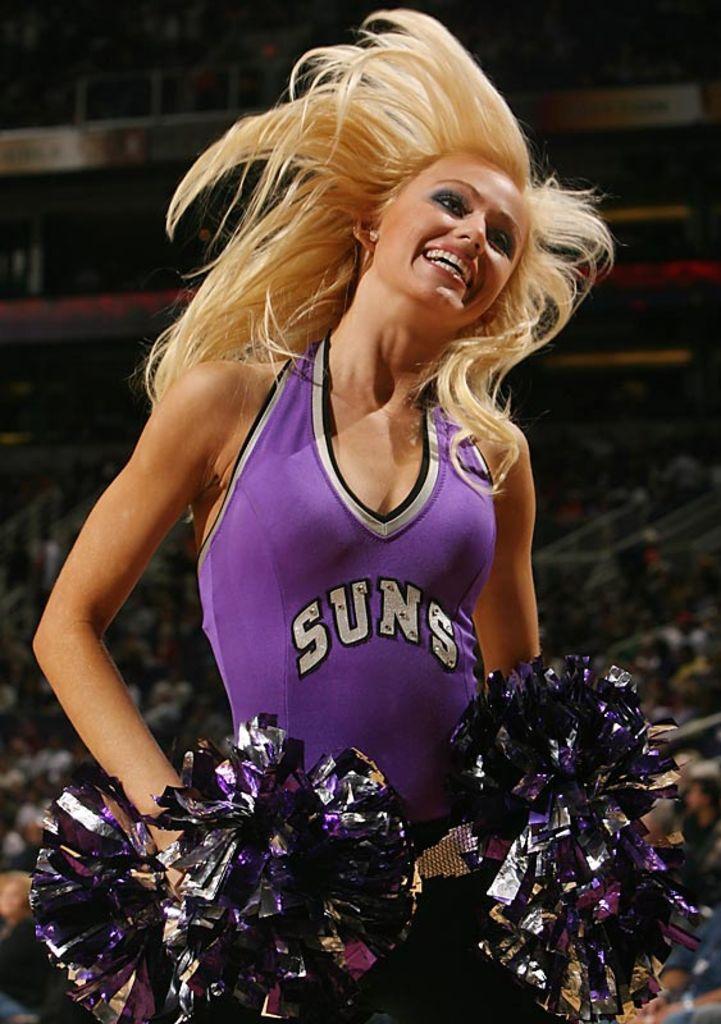What team does this cheerleader support?
Make the answer very short. Suns. 